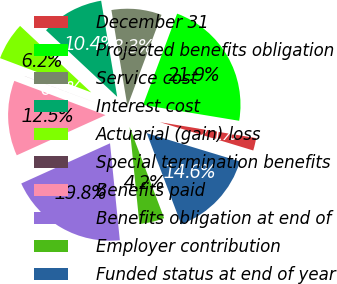<chart> <loc_0><loc_0><loc_500><loc_500><pie_chart><fcel>December 31<fcel>Projected benefits obligation<fcel>Service cost<fcel>Interest cost<fcel>Actuarial (gain) loss<fcel>Special termination benefits<fcel>Benefits paid<fcel>Benefits obligation at end of<fcel>Employer contribution<fcel>Funded status at end of year<nl><fcel>2.08%<fcel>21.92%<fcel>8.32%<fcel>10.4%<fcel>6.24%<fcel>0.01%<fcel>12.48%<fcel>19.84%<fcel>4.16%<fcel>14.55%<nl></chart> 